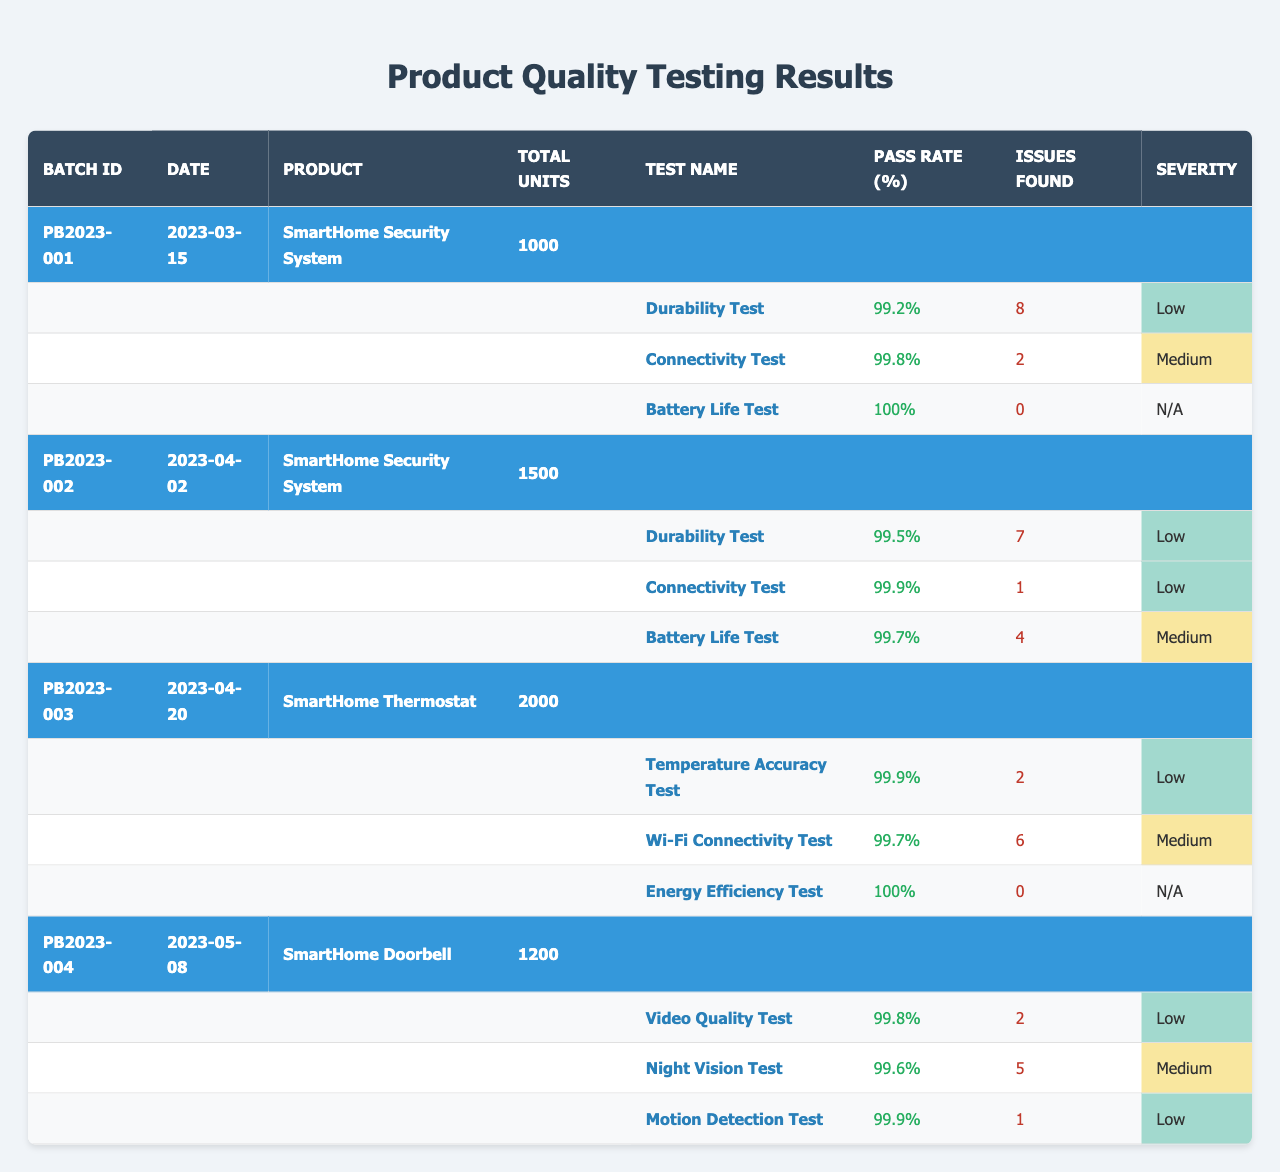What is the pass rate for the Battery Life Test in Batch ID PB2023-001? The table shows that under Batch ID PB2023-001, the Battery Life Test has a stated Pass Rate of 100%.
Answer: 100% Which batch had the highest total number of units produced? By comparing the total units for each batch, PB2023-003 has 2000 total units, which is higher than the others (PB2023-001: 1000, PB2023-002: 1500, PB2023-004: 1200).
Answer: PB2023-003 What is the average pass rate of the Durability Test across all batches? The Durability Test pass rates are 99.2%, 99.5%, and 99.9% from the respective batches. The average is calculated as (99.2 + 99.5 + 99.9 + 99.5) / 4 = 99.525%.
Answer: 99.525% How many issues were found in total across all units tested? Summing the issues for each batch: PB2023-001 (8) + PB2023-002 (7) + PB2023-003 (2) + PB2023-004 (8) = 25 issues found in total across all tests.
Answer: 25 Was there any test in Batch ID PB2023-003 that had a low severity of issues? In Batch ID PB2023-003, the Temperature Accuracy Test had a severity marked as Low, indicating it had some issues, but they were of lesser severity.
Answer: Yes What is the maximum number of issues found in a single test for all batches? Reviewing the issues found for each test, the maximum number is 8 from both the Durability Test in PB2023-001 and the Motion Detection Test in PB2023-004, indicating these tests had the highest number of identified issues.
Answer: 8 Which product had the lowest pass rate for any test, and what was the rate? The product "SmartHome Doorbell" had a Night Vision Test with a pass rate of 99.6%, which is the lowest among all tests across all products.
Answer: SmartHome Doorbell, 99.6% For the Connectivity Test in all batches, how many issues were found in total? The Connectivity Test issues were 2 in PB2023-001, 1 in PB2023-002, and 6 in PB2023-003, totaling 2 + 1 + 6 = 9 issues across the batches.
Answer: 9 Is there a test in any batch that had a pass rate of exactly 100%? Yes, both the Battery Life Test in Batch ID PB2023-001 and the Energy Efficiency Test in Batch ID PB2023-003 reported a pass rate of exactly 100%.
Answer: Yes What percentage of the total units produced in Batch ID PB2023-004 passed the Video Quality Test? The Video Quality Test in PB2023-004 had a pass rate of 99.8%, which means 99.8% of the 1200 units produced are expected to have passed the test.
Answer: 99.8% 